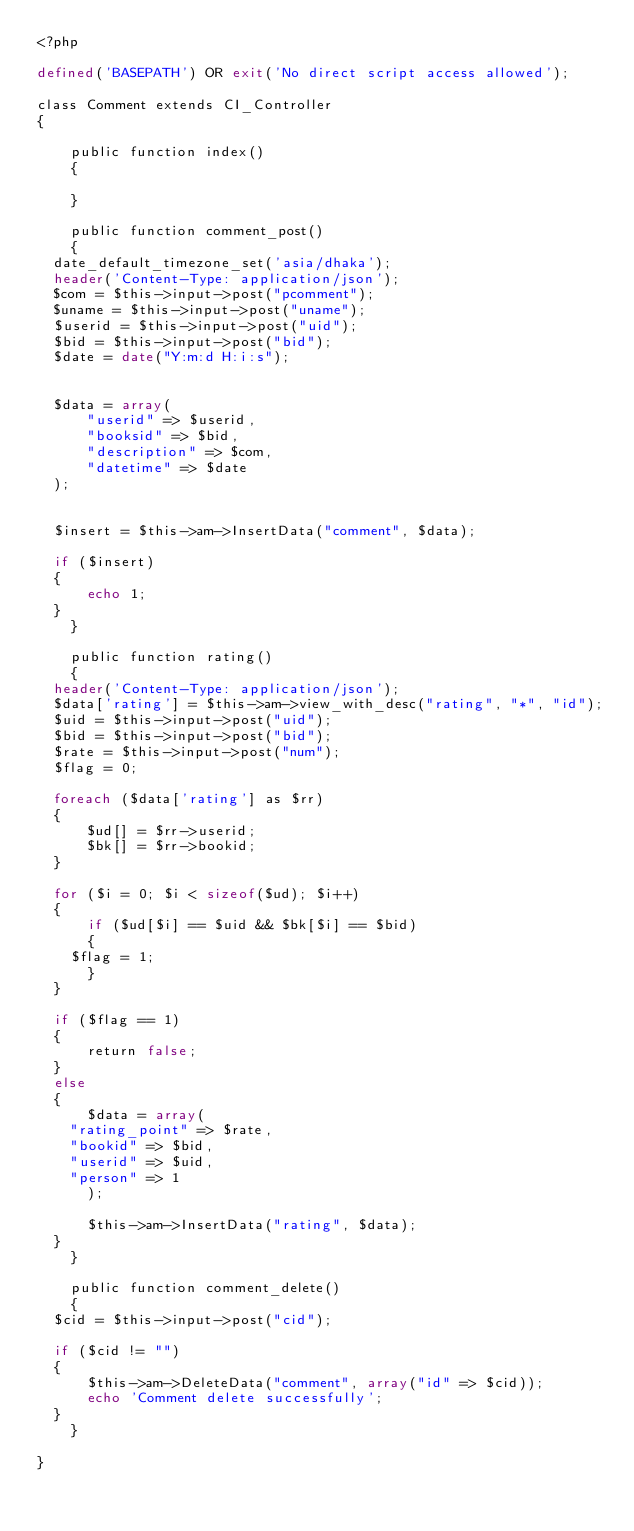Convert code to text. <code><loc_0><loc_0><loc_500><loc_500><_PHP_><?php

defined('BASEPATH') OR exit('No direct script access allowed');

class Comment extends CI_Controller
{

    public function index()
    {
	
    }

    public function comment_post()
    {
	date_default_timezone_set('asia/dhaka');
	header('Content-Type: application/json');
	$com = $this->input->post("pcomment");
	$uname = $this->input->post("uname");
	$userid = $this->input->post("uid");
	$bid = $this->input->post("bid");
	$date = date("Y:m:d H:i:s");


	$data = array(
	    "userid" => $userid,
	    "booksid" => $bid,
	    "description" => $com,
	    "datetime" => $date
	);


	$insert = $this->am->InsertData("comment", $data);

	if ($insert)
	{
	    echo 1;
	}
    }

    public function rating()
    {
	header('Content-Type: application/json');
	$data['rating'] = $this->am->view_with_desc("rating", "*", "id");
	$uid = $this->input->post("uid");
	$bid = $this->input->post("bid");
	$rate = $this->input->post("num");
	$flag = 0;

	foreach ($data['rating'] as $rr)
	{
	    $ud[] = $rr->userid;
	    $bk[] = $rr->bookid;
	}

	for ($i = 0; $i < sizeof($ud); $i++)
	{
	    if ($ud[$i] == $uid && $bk[$i] == $bid)
	    {
		$flag = 1;
	    }
	}

	if ($flag == 1)
	{
	    return false;
	}
	else
	{
	    $data = array(
		"rating_point" => $rate,
		"bookid" => $bid,
		"userid" => $uid,
		"person" => 1
	    );

	    $this->am->InsertData("rating", $data);
	}
    }

    public function comment_delete()
    {
	$cid = $this->input->post("cid");

	if ($cid != "")
	{
	    $this->am->DeleteData("comment", array("id" => $cid));
	    echo 'Comment delete successfully';
	}
    }

}
</code> 